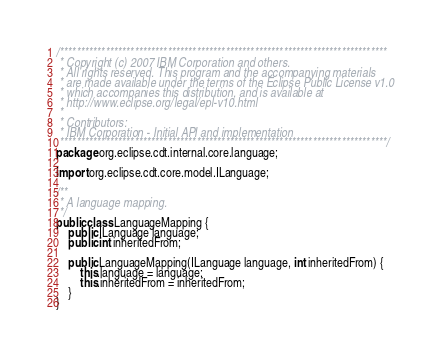Convert code to text. <code><loc_0><loc_0><loc_500><loc_500><_Java_>/*******************************************************************************
 * Copyright (c) 2007 IBM Corporation and others.
 * All rights reserved. This program and the accompanying materials
 * are made available under the terms of the Eclipse Public License v1.0
 * which accompanies this distribution, and is available at
 * http://www.eclipse.org/legal/epl-v10.html
 *
 * Contributors:
 * IBM Corporation - Initial API and implementation
 *******************************************************************************/
package org.eclipse.cdt.internal.core.language;

import org.eclipse.cdt.core.model.ILanguage;

/**
 * A language mapping.
 */
public class LanguageMapping {
	public ILanguage language;
	public int inheritedFrom;
	
	public LanguageMapping(ILanguage language, int inheritedFrom) {
		this.language = language;
		this.inheritedFrom = inheritedFrom;
	}
}
</code> 